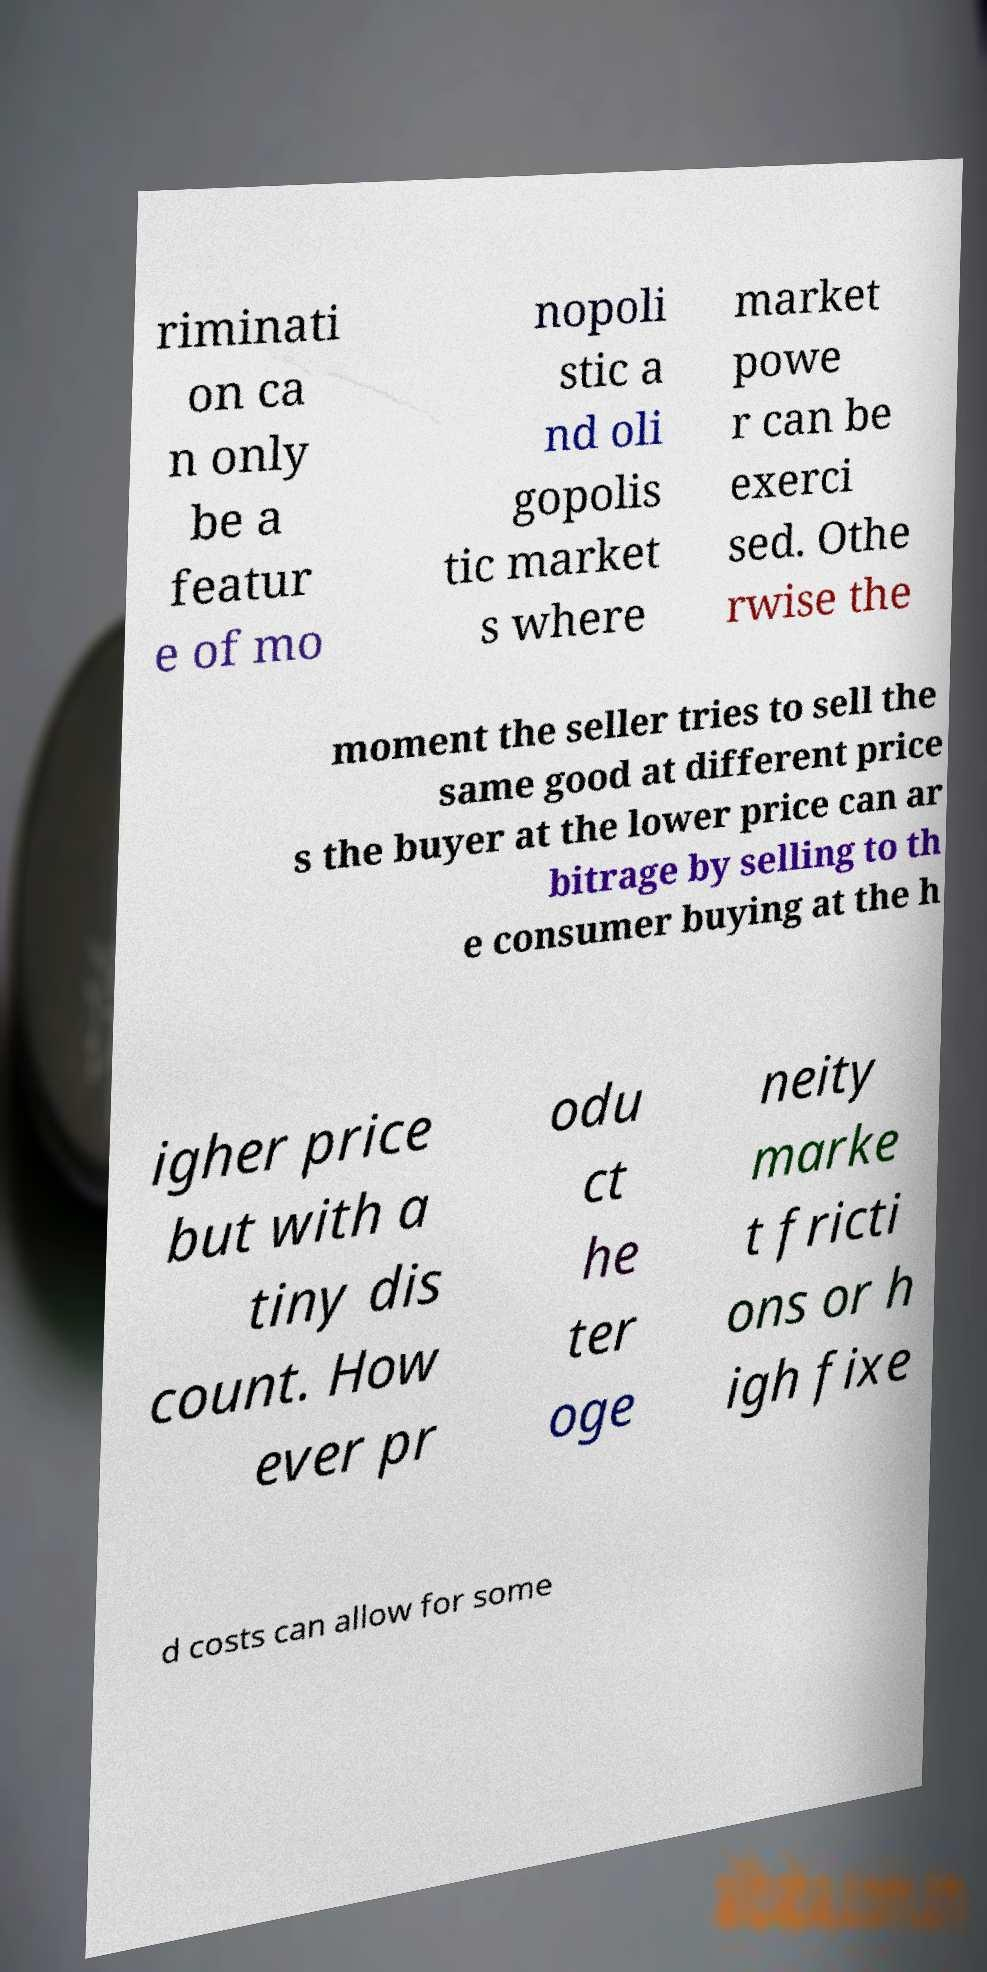For documentation purposes, I need the text within this image transcribed. Could you provide that? riminati on ca n only be a featur e of mo nopoli stic a nd oli gopolis tic market s where market powe r can be exerci sed. Othe rwise the moment the seller tries to sell the same good at different price s the buyer at the lower price can ar bitrage by selling to th e consumer buying at the h igher price but with a tiny dis count. How ever pr odu ct he ter oge neity marke t fricti ons or h igh fixe d costs can allow for some 